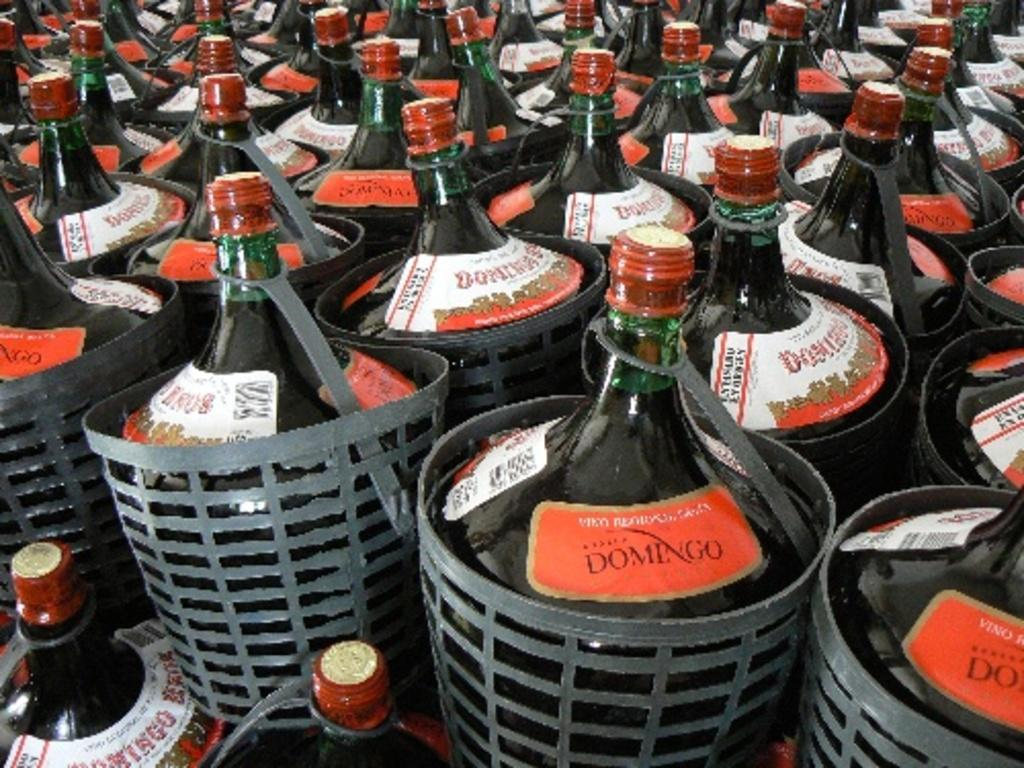<image>
Describe the image concisely. bottles in baskets that are all labeled 'domingo' 